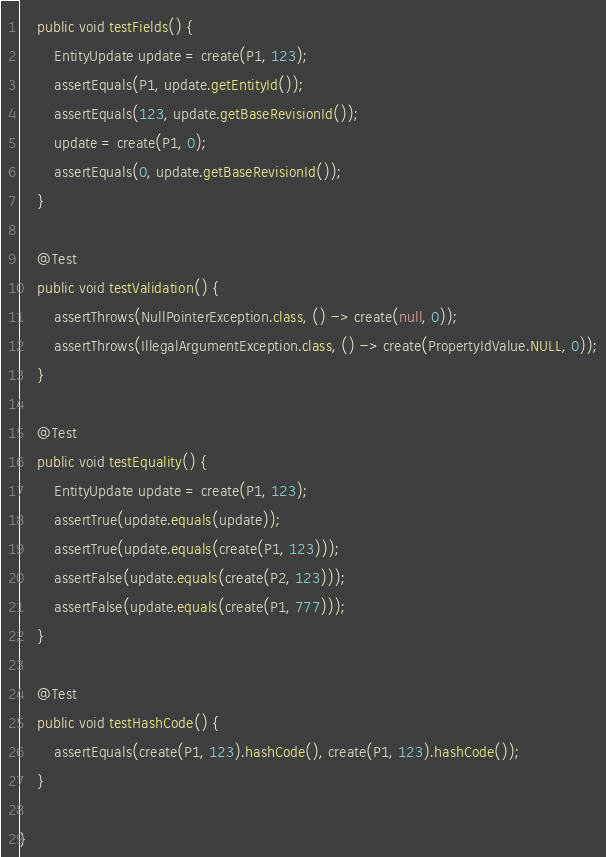<code> <loc_0><loc_0><loc_500><loc_500><_Java_>	public void testFields() {
		EntityUpdate update = create(P1, 123);
		assertEquals(P1, update.getEntityId());
		assertEquals(123, update.getBaseRevisionId());
		update = create(P1, 0);
		assertEquals(0, update.getBaseRevisionId());
	}

	@Test
	public void testValidation() {
		assertThrows(NullPointerException.class, () -> create(null, 0));
		assertThrows(IllegalArgumentException.class, () -> create(PropertyIdValue.NULL, 0));
	}

	@Test
	public void testEquality() {
		EntityUpdate update = create(P1, 123);
		assertTrue(update.equals(update));
		assertTrue(update.equals(create(P1, 123)));
		assertFalse(update.equals(create(P2, 123)));
		assertFalse(update.equals(create(P1, 777)));
	}

	@Test
	public void testHashCode() {
		assertEquals(create(P1, 123).hashCode(), create(P1, 123).hashCode());
	}

}
</code> 